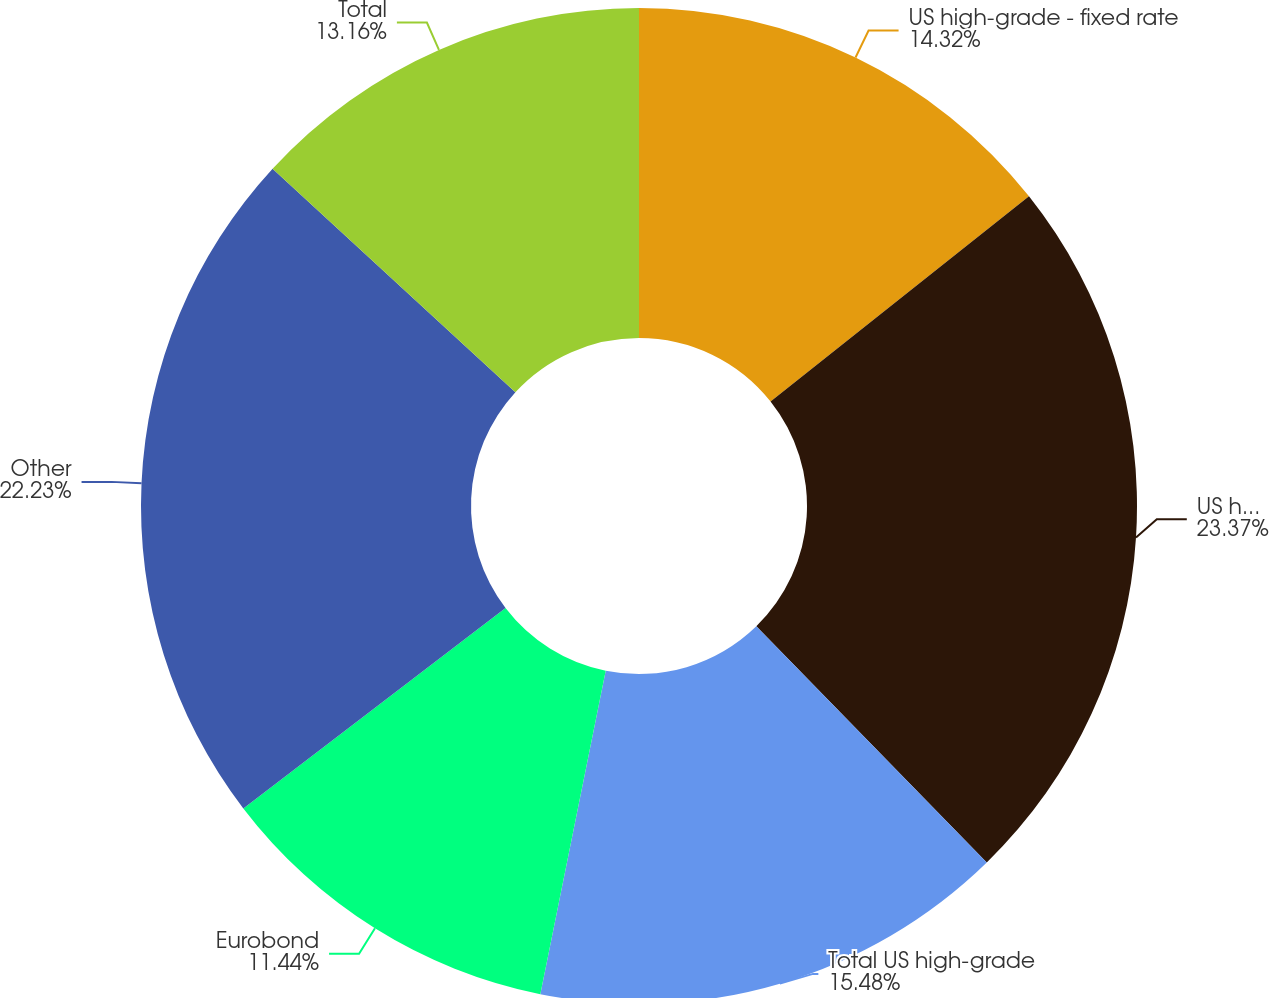<chart> <loc_0><loc_0><loc_500><loc_500><pie_chart><fcel>US high-grade - fixed rate<fcel>US high-grade - floating rate<fcel>Total US high-grade<fcel>Eurobond<fcel>Other<fcel>Total<nl><fcel>14.32%<fcel>23.38%<fcel>15.48%<fcel>11.44%<fcel>22.23%<fcel>13.16%<nl></chart> 